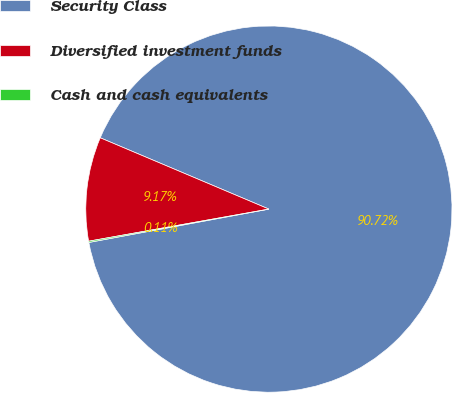Convert chart. <chart><loc_0><loc_0><loc_500><loc_500><pie_chart><fcel>Security Class<fcel>Diversified investment funds<fcel>Cash and cash equivalents<nl><fcel>90.71%<fcel>9.17%<fcel>0.11%<nl></chart> 